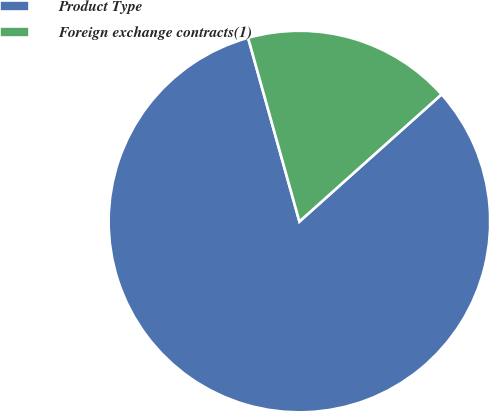Convert chart to OTSL. <chart><loc_0><loc_0><loc_500><loc_500><pie_chart><fcel>Product Type<fcel>Foreign exchange contracts(1)<nl><fcel>82.28%<fcel>17.72%<nl></chart> 